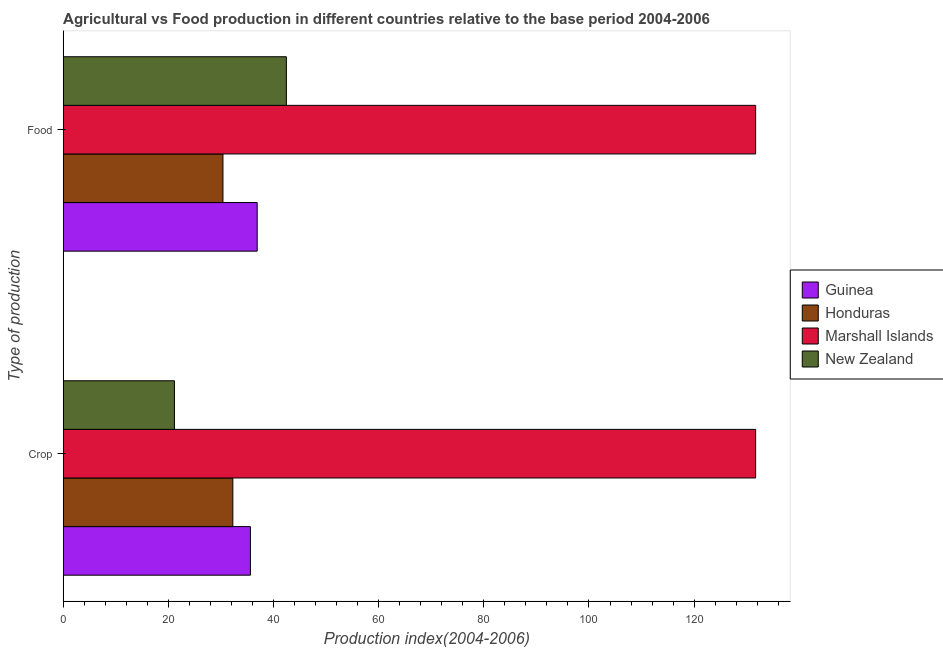How many different coloured bars are there?
Offer a terse response. 4. How many groups of bars are there?
Your answer should be compact. 2. Are the number of bars per tick equal to the number of legend labels?
Offer a very short reply. Yes. How many bars are there on the 1st tick from the top?
Ensure brevity in your answer.  4. How many bars are there on the 2nd tick from the bottom?
Offer a very short reply. 4. What is the label of the 2nd group of bars from the top?
Provide a short and direct response. Crop. What is the crop production index in Marshall Islands?
Your response must be concise. 131.7. Across all countries, what is the maximum food production index?
Your answer should be very brief. 131.7. Across all countries, what is the minimum crop production index?
Your answer should be very brief. 21.15. In which country was the crop production index maximum?
Ensure brevity in your answer.  Marshall Islands. In which country was the crop production index minimum?
Your answer should be compact. New Zealand. What is the total crop production index in the graph?
Your answer should be very brief. 220.71. What is the difference between the food production index in Marshall Islands and that in Honduras?
Offer a terse response. 101.32. What is the difference between the crop production index in New Zealand and the food production index in Honduras?
Your answer should be very brief. -9.23. What is the average food production index per country?
Offer a very short reply. 60.35. What is the difference between the crop production index and food production index in New Zealand?
Provide a succinct answer. -21.29. In how many countries, is the crop production index greater than 40 ?
Offer a terse response. 1. What is the ratio of the crop production index in Honduras to that in New Zealand?
Give a very brief answer. 1.53. In how many countries, is the food production index greater than the average food production index taken over all countries?
Provide a succinct answer. 1. What does the 2nd bar from the top in Food represents?
Provide a succinct answer. Marshall Islands. What does the 1st bar from the bottom in Food represents?
Make the answer very short. Guinea. How many bars are there?
Give a very brief answer. 8. Does the graph contain any zero values?
Your answer should be very brief. No. Where does the legend appear in the graph?
Keep it short and to the point. Center right. What is the title of the graph?
Provide a short and direct response. Agricultural vs Food production in different countries relative to the base period 2004-2006. What is the label or title of the X-axis?
Keep it short and to the point. Production index(2004-2006). What is the label or title of the Y-axis?
Ensure brevity in your answer.  Type of production. What is the Production index(2004-2006) in Guinea in Crop?
Make the answer very short. 35.6. What is the Production index(2004-2006) of Honduras in Crop?
Keep it short and to the point. 32.26. What is the Production index(2004-2006) in Marshall Islands in Crop?
Provide a short and direct response. 131.7. What is the Production index(2004-2006) of New Zealand in Crop?
Offer a very short reply. 21.15. What is the Production index(2004-2006) in Guinea in Food?
Your response must be concise. 36.89. What is the Production index(2004-2006) in Honduras in Food?
Give a very brief answer. 30.38. What is the Production index(2004-2006) of Marshall Islands in Food?
Offer a very short reply. 131.7. What is the Production index(2004-2006) of New Zealand in Food?
Make the answer very short. 42.44. Across all Type of production, what is the maximum Production index(2004-2006) of Guinea?
Your answer should be very brief. 36.89. Across all Type of production, what is the maximum Production index(2004-2006) of Honduras?
Provide a short and direct response. 32.26. Across all Type of production, what is the maximum Production index(2004-2006) of Marshall Islands?
Ensure brevity in your answer.  131.7. Across all Type of production, what is the maximum Production index(2004-2006) of New Zealand?
Make the answer very short. 42.44. Across all Type of production, what is the minimum Production index(2004-2006) in Guinea?
Offer a terse response. 35.6. Across all Type of production, what is the minimum Production index(2004-2006) of Honduras?
Offer a very short reply. 30.38. Across all Type of production, what is the minimum Production index(2004-2006) of Marshall Islands?
Make the answer very short. 131.7. Across all Type of production, what is the minimum Production index(2004-2006) of New Zealand?
Keep it short and to the point. 21.15. What is the total Production index(2004-2006) of Guinea in the graph?
Give a very brief answer. 72.49. What is the total Production index(2004-2006) of Honduras in the graph?
Provide a short and direct response. 62.64. What is the total Production index(2004-2006) of Marshall Islands in the graph?
Offer a very short reply. 263.4. What is the total Production index(2004-2006) of New Zealand in the graph?
Your answer should be compact. 63.59. What is the difference between the Production index(2004-2006) in Guinea in Crop and that in Food?
Make the answer very short. -1.29. What is the difference between the Production index(2004-2006) of Honduras in Crop and that in Food?
Your answer should be very brief. 1.88. What is the difference between the Production index(2004-2006) in Marshall Islands in Crop and that in Food?
Provide a short and direct response. 0. What is the difference between the Production index(2004-2006) in New Zealand in Crop and that in Food?
Your response must be concise. -21.29. What is the difference between the Production index(2004-2006) of Guinea in Crop and the Production index(2004-2006) of Honduras in Food?
Offer a terse response. 5.22. What is the difference between the Production index(2004-2006) in Guinea in Crop and the Production index(2004-2006) in Marshall Islands in Food?
Keep it short and to the point. -96.1. What is the difference between the Production index(2004-2006) of Guinea in Crop and the Production index(2004-2006) of New Zealand in Food?
Your response must be concise. -6.84. What is the difference between the Production index(2004-2006) in Honduras in Crop and the Production index(2004-2006) in Marshall Islands in Food?
Provide a short and direct response. -99.44. What is the difference between the Production index(2004-2006) in Honduras in Crop and the Production index(2004-2006) in New Zealand in Food?
Provide a succinct answer. -10.18. What is the difference between the Production index(2004-2006) in Marshall Islands in Crop and the Production index(2004-2006) in New Zealand in Food?
Provide a succinct answer. 89.26. What is the average Production index(2004-2006) in Guinea per Type of production?
Ensure brevity in your answer.  36.24. What is the average Production index(2004-2006) in Honduras per Type of production?
Provide a succinct answer. 31.32. What is the average Production index(2004-2006) of Marshall Islands per Type of production?
Provide a succinct answer. 131.7. What is the average Production index(2004-2006) of New Zealand per Type of production?
Make the answer very short. 31.8. What is the difference between the Production index(2004-2006) of Guinea and Production index(2004-2006) of Honduras in Crop?
Give a very brief answer. 3.34. What is the difference between the Production index(2004-2006) in Guinea and Production index(2004-2006) in Marshall Islands in Crop?
Provide a succinct answer. -96.1. What is the difference between the Production index(2004-2006) of Guinea and Production index(2004-2006) of New Zealand in Crop?
Provide a short and direct response. 14.45. What is the difference between the Production index(2004-2006) of Honduras and Production index(2004-2006) of Marshall Islands in Crop?
Offer a terse response. -99.44. What is the difference between the Production index(2004-2006) in Honduras and Production index(2004-2006) in New Zealand in Crop?
Your response must be concise. 11.11. What is the difference between the Production index(2004-2006) in Marshall Islands and Production index(2004-2006) in New Zealand in Crop?
Offer a terse response. 110.55. What is the difference between the Production index(2004-2006) of Guinea and Production index(2004-2006) of Honduras in Food?
Give a very brief answer. 6.51. What is the difference between the Production index(2004-2006) of Guinea and Production index(2004-2006) of Marshall Islands in Food?
Your answer should be compact. -94.81. What is the difference between the Production index(2004-2006) in Guinea and Production index(2004-2006) in New Zealand in Food?
Your response must be concise. -5.55. What is the difference between the Production index(2004-2006) of Honduras and Production index(2004-2006) of Marshall Islands in Food?
Offer a terse response. -101.32. What is the difference between the Production index(2004-2006) of Honduras and Production index(2004-2006) of New Zealand in Food?
Your answer should be very brief. -12.06. What is the difference between the Production index(2004-2006) of Marshall Islands and Production index(2004-2006) of New Zealand in Food?
Provide a succinct answer. 89.26. What is the ratio of the Production index(2004-2006) of Guinea in Crop to that in Food?
Provide a short and direct response. 0.96. What is the ratio of the Production index(2004-2006) of Honduras in Crop to that in Food?
Keep it short and to the point. 1.06. What is the ratio of the Production index(2004-2006) in Marshall Islands in Crop to that in Food?
Your answer should be very brief. 1. What is the ratio of the Production index(2004-2006) in New Zealand in Crop to that in Food?
Ensure brevity in your answer.  0.5. What is the difference between the highest and the second highest Production index(2004-2006) of Guinea?
Give a very brief answer. 1.29. What is the difference between the highest and the second highest Production index(2004-2006) of Honduras?
Offer a very short reply. 1.88. What is the difference between the highest and the second highest Production index(2004-2006) of Marshall Islands?
Keep it short and to the point. 0. What is the difference between the highest and the second highest Production index(2004-2006) of New Zealand?
Keep it short and to the point. 21.29. What is the difference between the highest and the lowest Production index(2004-2006) in Guinea?
Offer a terse response. 1.29. What is the difference between the highest and the lowest Production index(2004-2006) in Honduras?
Ensure brevity in your answer.  1.88. What is the difference between the highest and the lowest Production index(2004-2006) in Marshall Islands?
Ensure brevity in your answer.  0. What is the difference between the highest and the lowest Production index(2004-2006) in New Zealand?
Offer a very short reply. 21.29. 